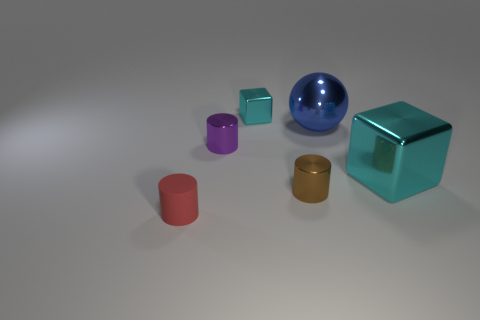Is there a small brown metallic thing of the same shape as the large cyan object?
Ensure brevity in your answer.  No. There is a red rubber cylinder; is its size the same as the cyan object behind the small purple object?
Provide a succinct answer. Yes. How many things are tiny cylinders that are on the right side of the tiny rubber cylinder or tiny shiny cylinders to the right of the tiny cyan object?
Your response must be concise. 2. Are there more big shiny spheres that are in front of the tiny brown shiny cylinder than blue things?
Provide a succinct answer. No. What number of other brown things have the same size as the brown metallic thing?
Offer a terse response. 0. Is the size of the cyan metallic block that is to the left of the tiny brown object the same as the rubber object that is left of the big cyan shiny thing?
Your response must be concise. Yes. What is the size of the cyan metallic cube to the left of the brown metal cylinder?
Provide a succinct answer. Small. What is the size of the block that is in front of the cyan shiny block on the left side of the large blue ball?
Give a very brief answer. Large. There is a cube that is the same size as the blue thing; what is its material?
Your response must be concise. Metal. There is a purple metal object; are there any tiny cubes left of it?
Make the answer very short. No. 